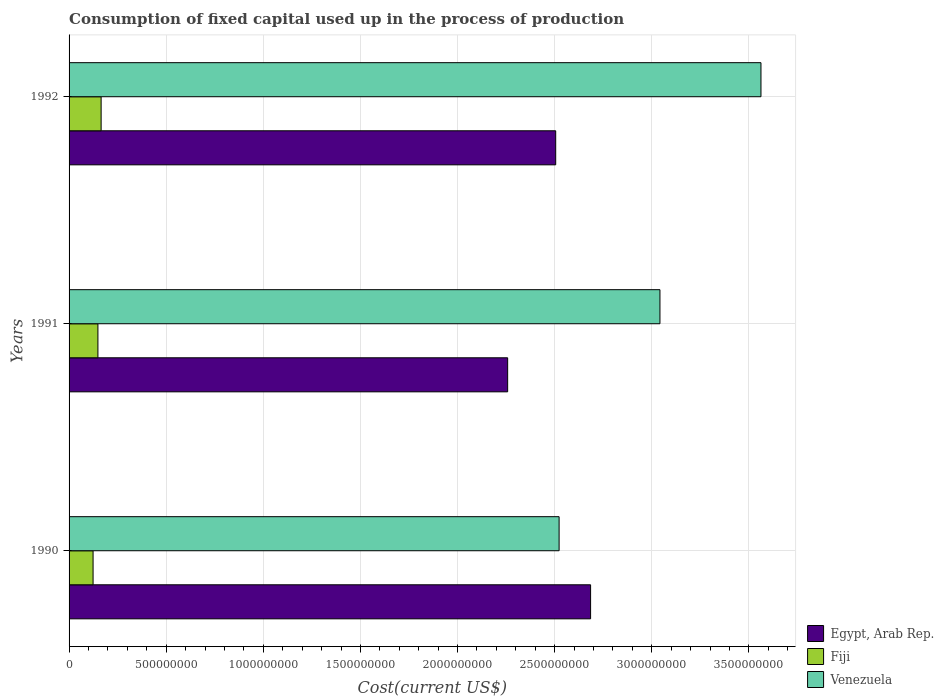How many different coloured bars are there?
Offer a terse response. 3. How many groups of bars are there?
Give a very brief answer. 3. Are the number of bars per tick equal to the number of legend labels?
Your response must be concise. Yes. How many bars are there on the 1st tick from the top?
Offer a terse response. 3. How many bars are there on the 3rd tick from the bottom?
Offer a terse response. 3. In how many cases, is the number of bars for a given year not equal to the number of legend labels?
Ensure brevity in your answer.  0. What is the amount consumed in the process of production in Fiji in 1992?
Your response must be concise. 1.65e+08. Across all years, what is the maximum amount consumed in the process of production in Venezuela?
Your answer should be very brief. 3.56e+09. Across all years, what is the minimum amount consumed in the process of production in Venezuela?
Make the answer very short. 2.52e+09. In which year was the amount consumed in the process of production in Egypt, Arab Rep. maximum?
Your answer should be very brief. 1990. In which year was the amount consumed in the process of production in Fiji minimum?
Offer a terse response. 1990. What is the total amount consumed in the process of production in Fiji in the graph?
Offer a terse response. 4.37e+08. What is the difference between the amount consumed in the process of production in Venezuela in 1990 and that in 1991?
Your answer should be very brief. -5.19e+08. What is the difference between the amount consumed in the process of production in Fiji in 1990 and the amount consumed in the process of production in Egypt, Arab Rep. in 1991?
Your answer should be very brief. -2.13e+09. What is the average amount consumed in the process of production in Egypt, Arab Rep. per year?
Provide a succinct answer. 2.48e+09. In the year 1992, what is the difference between the amount consumed in the process of production in Venezuela and amount consumed in the process of production in Egypt, Arab Rep.?
Your answer should be compact. 1.06e+09. In how many years, is the amount consumed in the process of production in Fiji greater than 3000000000 US$?
Your response must be concise. 0. What is the ratio of the amount consumed in the process of production in Fiji in 1991 to that in 1992?
Make the answer very short. 0.9. Is the amount consumed in the process of production in Egypt, Arab Rep. in 1990 less than that in 1991?
Your answer should be compact. No. What is the difference between the highest and the second highest amount consumed in the process of production in Venezuela?
Ensure brevity in your answer.  5.20e+08. What is the difference between the highest and the lowest amount consumed in the process of production in Fiji?
Ensure brevity in your answer.  4.15e+07. What does the 3rd bar from the top in 1990 represents?
Your answer should be compact. Egypt, Arab Rep. What does the 3rd bar from the bottom in 1991 represents?
Your answer should be compact. Venezuela. Are the values on the major ticks of X-axis written in scientific E-notation?
Ensure brevity in your answer.  No. Does the graph contain any zero values?
Keep it short and to the point. No. Does the graph contain grids?
Ensure brevity in your answer.  Yes. How many legend labels are there?
Your answer should be compact. 3. What is the title of the graph?
Your response must be concise. Consumption of fixed capital used up in the process of production. Does "Tunisia" appear as one of the legend labels in the graph?
Provide a succinct answer. No. What is the label or title of the X-axis?
Keep it short and to the point. Cost(current US$). What is the Cost(current US$) in Egypt, Arab Rep. in 1990?
Offer a very short reply. 2.68e+09. What is the Cost(current US$) of Fiji in 1990?
Your answer should be compact. 1.24e+08. What is the Cost(current US$) in Venezuela in 1990?
Offer a very short reply. 2.52e+09. What is the Cost(current US$) of Egypt, Arab Rep. in 1991?
Your answer should be very brief. 2.26e+09. What is the Cost(current US$) in Fiji in 1991?
Your answer should be compact. 1.49e+08. What is the Cost(current US$) of Venezuela in 1991?
Offer a very short reply. 3.04e+09. What is the Cost(current US$) of Egypt, Arab Rep. in 1992?
Ensure brevity in your answer.  2.51e+09. What is the Cost(current US$) of Fiji in 1992?
Ensure brevity in your answer.  1.65e+08. What is the Cost(current US$) in Venezuela in 1992?
Provide a short and direct response. 3.56e+09. Across all years, what is the maximum Cost(current US$) of Egypt, Arab Rep.?
Your answer should be very brief. 2.68e+09. Across all years, what is the maximum Cost(current US$) of Fiji?
Your answer should be compact. 1.65e+08. Across all years, what is the maximum Cost(current US$) of Venezuela?
Offer a terse response. 3.56e+09. Across all years, what is the minimum Cost(current US$) in Egypt, Arab Rep.?
Your answer should be compact. 2.26e+09. Across all years, what is the minimum Cost(current US$) in Fiji?
Ensure brevity in your answer.  1.24e+08. Across all years, what is the minimum Cost(current US$) in Venezuela?
Ensure brevity in your answer.  2.52e+09. What is the total Cost(current US$) of Egypt, Arab Rep. in the graph?
Provide a short and direct response. 7.45e+09. What is the total Cost(current US$) of Fiji in the graph?
Your response must be concise. 4.37e+08. What is the total Cost(current US$) of Venezuela in the graph?
Provide a short and direct response. 9.13e+09. What is the difference between the Cost(current US$) in Egypt, Arab Rep. in 1990 and that in 1991?
Ensure brevity in your answer.  4.27e+08. What is the difference between the Cost(current US$) of Fiji in 1990 and that in 1991?
Your response must be concise. -2.50e+07. What is the difference between the Cost(current US$) in Venezuela in 1990 and that in 1991?
Keep it short and to the point. -5.19e+08. What is the difference between the Cost(current US$) of Egypt, Arab Rep. in 1990 and that in 1992?
Give a very brief answer. 1.80e+08. What is the difference between the Cost(current US$) of Fiji in 1990 and that in 1992?
Offer a very short reply. -4.15e+07. What is the difference between the Cost(current US$) of Venezuela in 1990 and that in 1992?
Offer a very short reply. -1.04e+09. What is the difference between the Cost(current US$) in Egypt, Arab Rep. in 1991 and that in 1992?
Your response must be concise. -2.47e+08. What is the difference between the Cost(current US$) in Fiji in 1991 and that in 1992?
Provide a short and direct response. -1.65e+07. What is the difference between the Cost(current US$) of Venezuela in 1991 and that in 1992?
Provide a succinct answer. -5.20e+08. What is the difference between the Cost(current US$) in Egypt, Arab Rep. in 1990 and the Cost(current US$) in Fiji in 1991?
Your answer should be very brief. 2.54e+09. What is the difference between the Cost(current US$) in Egypt, Arab Rep. in 1990 and the Cost(current US$) in Venezuela in 1991?
Offer a terse response. -3.57e+08. What is the difference between the Cost(current US$) of Fiji in 1990 and the Cost(current US$) of Venezuela in 1991?
Ensure brevity in your answer.  -2.92e+09. What is the difference between the Cost(current US$) in Egypt, Arab Rep. in 1990 and the Cost(current US$) in Fiji in 1992?
Your answer should be compact. 2.52e+09. What is the difference between the Cost(current US$) of Egypt, Arab Rep. in 1990 and the Cost(current US$) of Venezuela in 1992?
Give a very brief answer. -8.77e+08. What is the difference between the Cost(current US$) of Fiji in 1990 and the Cost(current US$) of Venezuela in 1992?
Keep it short and to the point. -3.44e+09. What is the difference between the Cost(current US$) in Egypt, Arab Rep. in 1991 and the Cost(current US$) in Fiji in 1992?
Keep it short and to the point. 2.09e+09. What is the difference between the Cost(current US$) in Egypt, Arab Rep. in 1991 and the Cost(current US$) in Venezuela in 1992?
Ensure brevity in your answer.  -1.30e+09. What is the difference between the Cost(current US$) of Fiji in 1991 and the Cost(current US$) of Venezuela in 1992?
Offer a terse response. -3.41e+09. What is the average Cost(current US$) of Egypt, Arab Rep. per year?
Make the answer very short. 2.48e+09. What is the average Cost(current US$) of Fiji per year?
Provide a short and direct response. 1.46e+08. What is the average Cost(current US$) in Venezuela per year?
Offer a terse response. 3.04e+09. In the year 1990, what is the difference between the Cost(current US$) of Egypt, Arab Rep. and Cost(current US$) of Fiji?
Provide a short and direct response. 2.56e+09. In the year 1990, what is the difference between the Cost(current US$) of Egypt, Arab Rep. and Cost(current US$) of Venezuela?
Make the answer very short. 1.62e+08. In the year 1990, what is the difference between the Cost(current US$) in Fiji and Cost(current US$) in Venezuela?
Give a very brief answer. -2.40e+09. In the year 1991, what is the difference between the Cost(current US$) of Egypt, Arab Rep. and Cost(current US$) of Fiji?
Offer a terse response. 2.11e+09. In the year 1991, what is the difference between the Cost(current US$) in Egypt, Arab Rep. and Cost(current US$) in Venezuela?
Your answer should be very brief. -7.84e+08. In the year 1991, what is the difference between the Cost(current US$) of Fiji and Cost(current US$) of Venezuela?
Make the answer very short. -2.89e+09. In the year 1992, what is the difference between the Cost(current US$) in Egypt, Arab Rep. and Cost(current US$) in Fiji?
Your answer should be very brief. 2.34e+09. In the year 1992, what is the difference between the Cost(current US$) of Egypt, Arab Rep. and Cost(current US$) of Venezuela?
Offer a terse response. -1.06e+09. In the year 1992, what is the difference between the Cost(current US$) in Fiji and Cost(current US$) in Venezuela?
Make the answer very short. -3.40e+09. What is the ratio of the Cost(current US$) in Egypt, Arab Rep. in 1990 to that in 1991?
Offer a very short reply. 1.19. What is the ratio of the Cost(current US$) in Fiji in 1990 to that in 1991?
Provide a short and direct response. 0.83. What is the ratio of the Cost(current US$) in Venezuela in 1990 to that in 1991?
Your answer should be very brief. 0.83. What is the ratio of the Cost(current US$) of Egypt, Arab Rep. in 1990 to that in 1992?
Offer a terse response. 1.07. What is the ratio of the Cost(current US$) in Fiji in 1990 to that in 1992?
Offer a very short reply. 0.75. What is the ratio of the Cost(current US$) of Venezuela in 1990 to that in 1992?
Keep it short and to the point. 0.71. What is the ratio of the Cost(current US$) in Egypt, Arab Rep. in 1991 to that in 1992?
Make the answer very short. 0.9. What is the ratio of the Cost(current US$) in Fiji in 1991 to that in 1992?
Offer a terse response. 0.9. What is the ratio of the Cost(current US$) in Venezuela in 1991 to that in 1992?
Your answer should be compact. 0.85. What is the difference between the highest and the second highest Cost(current US$) in Egypt, Arab Rep.?
Keep it short and to the point. 1.80e+08. What is the difference between the highest and the second highest Cost(current US$) in Fiji?
Offer a very short reply. 1.65e+07. What is the difference between the highest and the second highest Cost(current US$) in Venezuela?
Your response must be concise. 5.20e+08. What is the difference between the highest and the lowest Cost(current US$) in Egypt, Arab Rep.?
Your answer should be very brief. 4.27e+08. What is the difference between the highest and the lowest Cost(current US$) in Fiji?
Make the answer very short. 4.15e+07. What is the difference between the highest and the lowest Cost(current US$) of Venezuela?
Offer a terse response. 1.04e+09. 